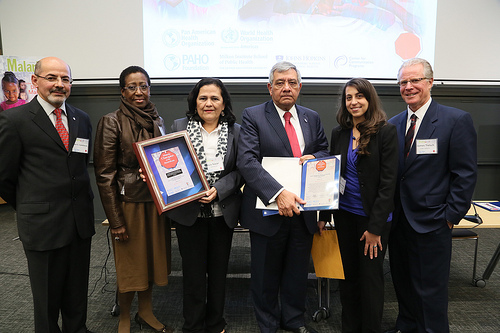<image>
Can you confirm if the table is in front of the man? No. The table is not in front of the man. The spatial positioning shows a different relationship between these objects. 